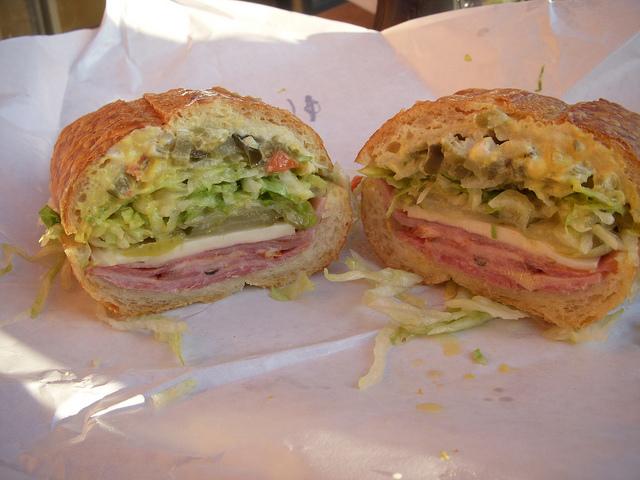What type of food is this?
Answer briefly. Sandwich. Who took a bite out of this?
Short answer required. No one. Are there any utensils in this scene?
Keep it brief. No. What kind of sandwich is this?
Be succinct. Ham and cheese. What is the sandwich made of?
Keep it brief. Bread. How many pieces of sandwich are there?
Keep it brief. 2. What is the sandwich served with?
Short answer required. Nothing. Would a vegetarian eat this?
Be succinct. No. What kind of sandwich is in the picture?
Quick response, please. Ham and cheese. Is this a turkey sandwich?
Short answer required. No. What meat is on the sandwich?
Be succinct. Ham. Where are the sandwiches?
Be succinct. On paper. Does this sandwich have red pepper on it?
Short answer required. No. What kind of sandwich is it?
Give a very brief answer. Ham. What are the sandwiches on?
Keep it brief. Paper. 